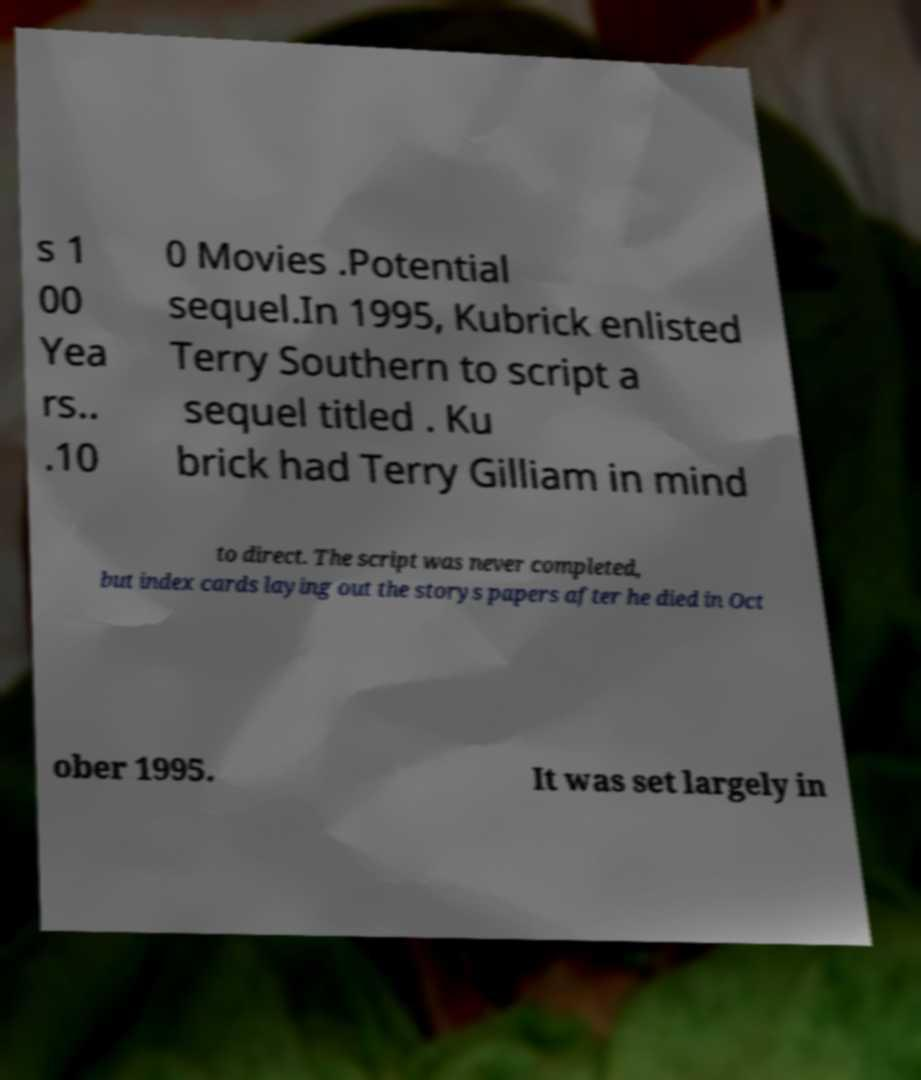There's text embedded in this image that I need extracted. Can you transcribe it verbatim? s 1 00 Yea rs.. .10 0 Movies .Potential sequel.In 1995, Kubrick enlisted Terry Southern to script a sequel titled . Ku brick had Terry Gilliam in mind to direct. The script was never completed, but index cards laying out the storys papers after he died in Oct ober 1995. It was set largely in 